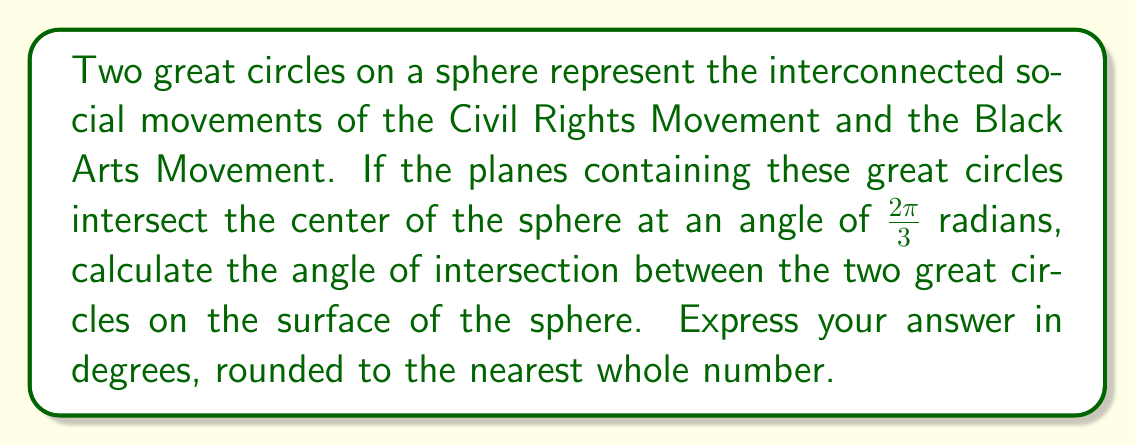Give your solution to this math problem. Let's approach this step-by-step:

1) In spherical geometry, the angle between two great circles on the surface of a sphere is equal to the angle between the planes that contain these great circles.

2) We are given that the planes intersect at the center of the sphere at an angle of $\frac{2\pi}{3}$ radians.

3) To convert radians to degrees, we use the formula:
   $\text{degrees} = \text{radians} \times \frac{180^{\circ}}{\pi}$

4) Substituting our angle:
   $\text{degrees} = \frac{2\pi}{3} \times \frac{180^{\circ}}{\pi}$

5) Simplifying:
   $\text{degrees} = \frac{2 \times 180^{\circ}}{3} = 120^{\circ}$

6) The question asks for the answer rounded to the nearest whole number, but 120° is already a whole number, so no rounding is necessary.

[asy]
import geometry;

size(200);
draw(circle((0,0),1));
draw((-1,0)--(1,0));
draw((0,-1)--(0,1));
draw(arc((0,0),1,0,120),red);
label("120°",(0.5,0.3),NE);
[/asy]

This diagram illustrates the intersection of two great circles on a sphere, forming an angle of 120°.
Answer: 120° 